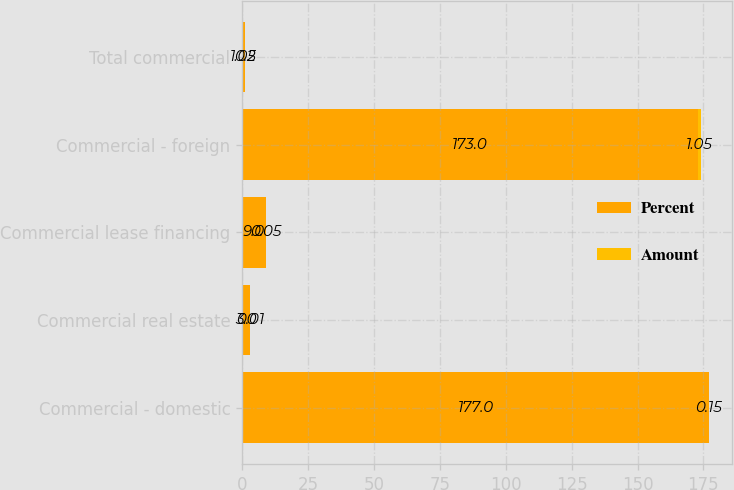Convert chart. <chart><loc_0><loc_0><loc_500><loc_500><stacked_bar_chart><ecel><fcel>Commercial - domestic<fcel>Commercial real estate<fcel>Commercial lease financing<fcel>Commercial - foreign<fcel>Total commercial<nl><fcel>Percent<fcel>177<fcel>3<fcel>9<fcel>173<fcel>1.05<nl><fcel>Amount<fcel>0.15<fcel>0.01<fcel>0.05<fcel>1.05<fcel>0.2<nl></chart> 